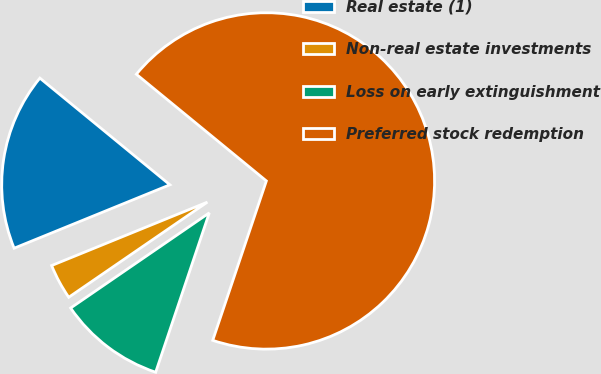<chart> <loc_0><loc_0><loc_500><loc_500><pie_chart><fcel>Real estate (1)<fcel>Non-real estate investments<fcel>Loss on early extinguishment<fcel>Preferred stock redemption<nl><fcel>17.09%<fcel>3.42%<fcel>10.26%<fcel>69.23%<nl></chart> 